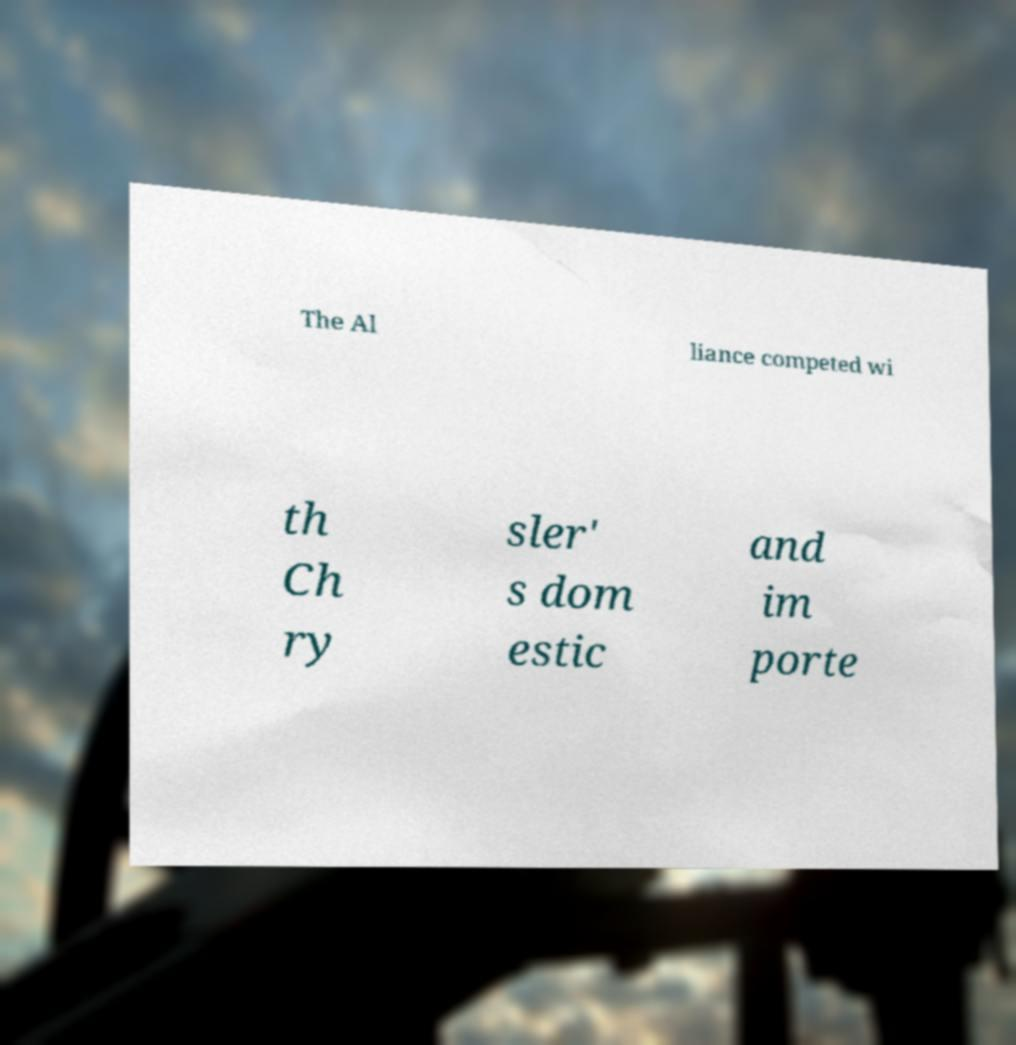For documentation purposes, I need the text within this image transcribed. Could you provide that? The Al liance competed wi th Ch ry sler' s dom estic and im porte 